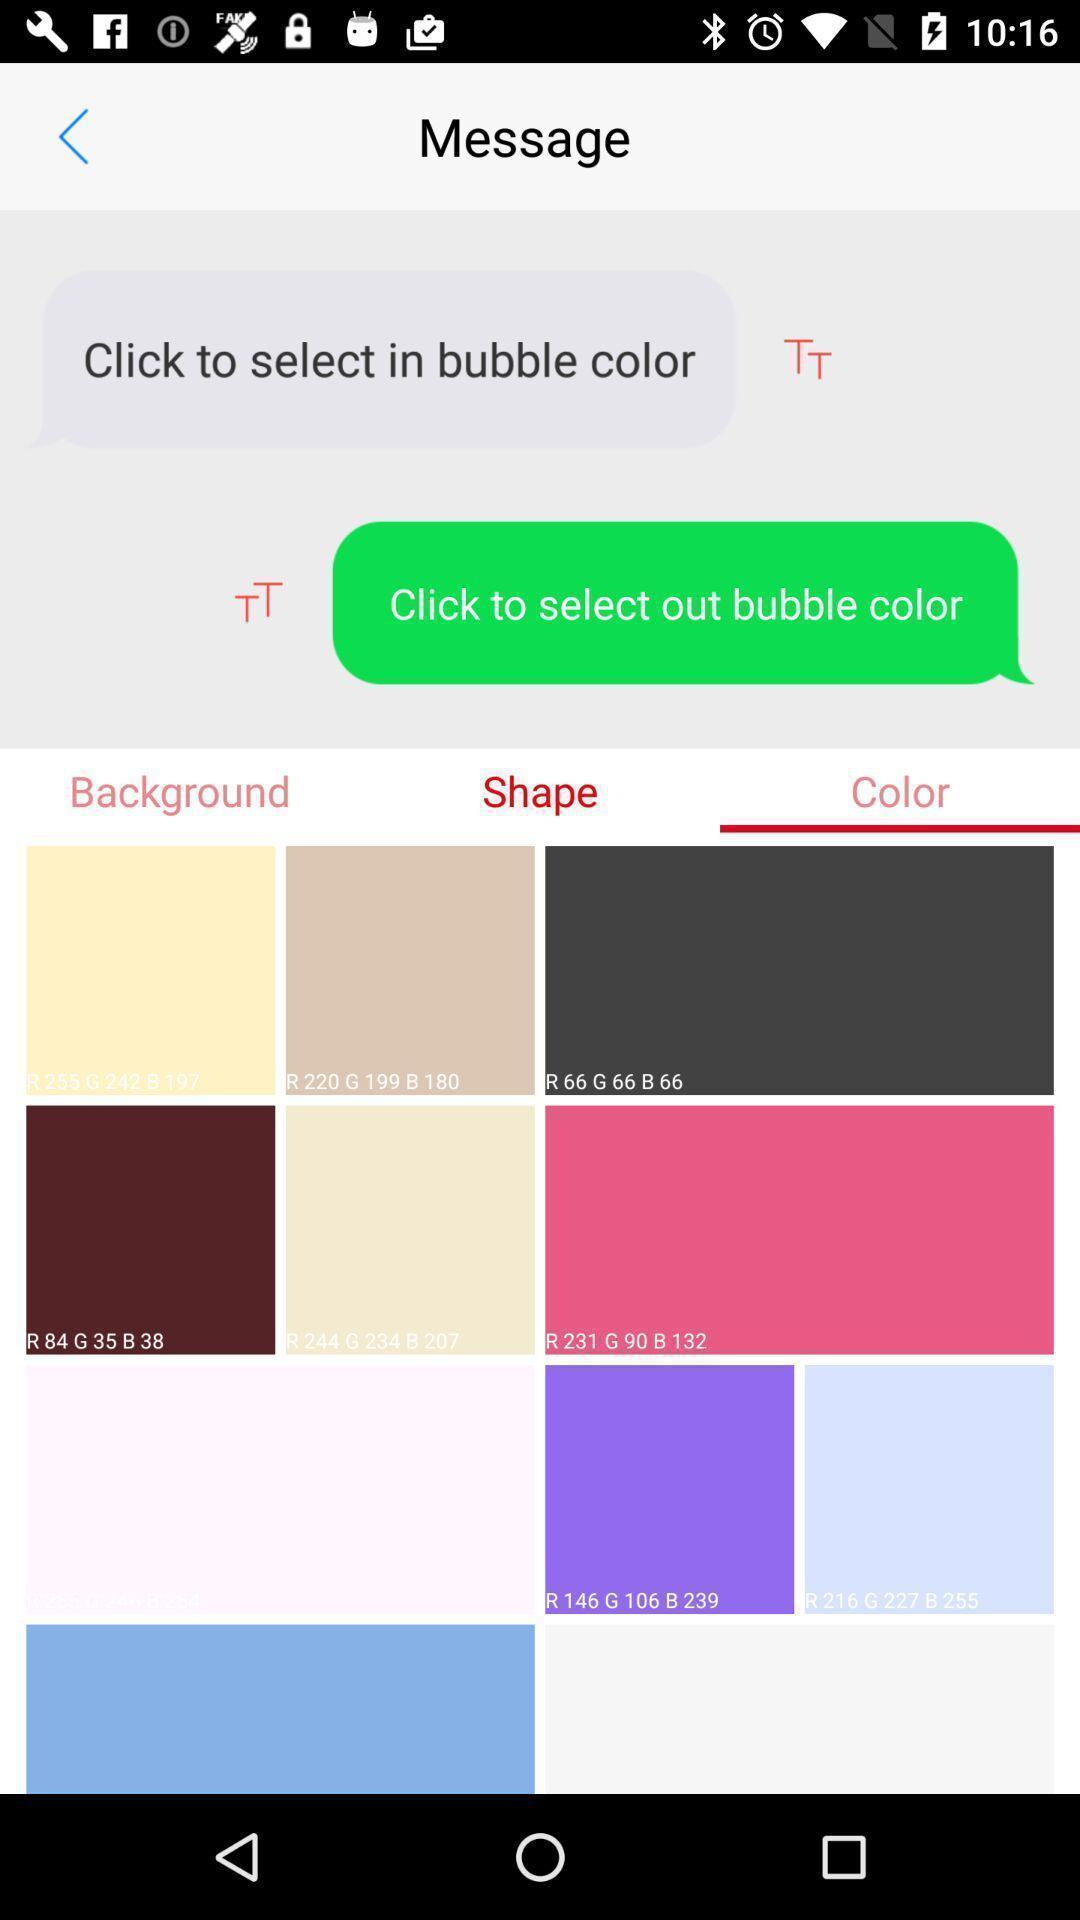Please provide a description for this image. Page showing different colors. 